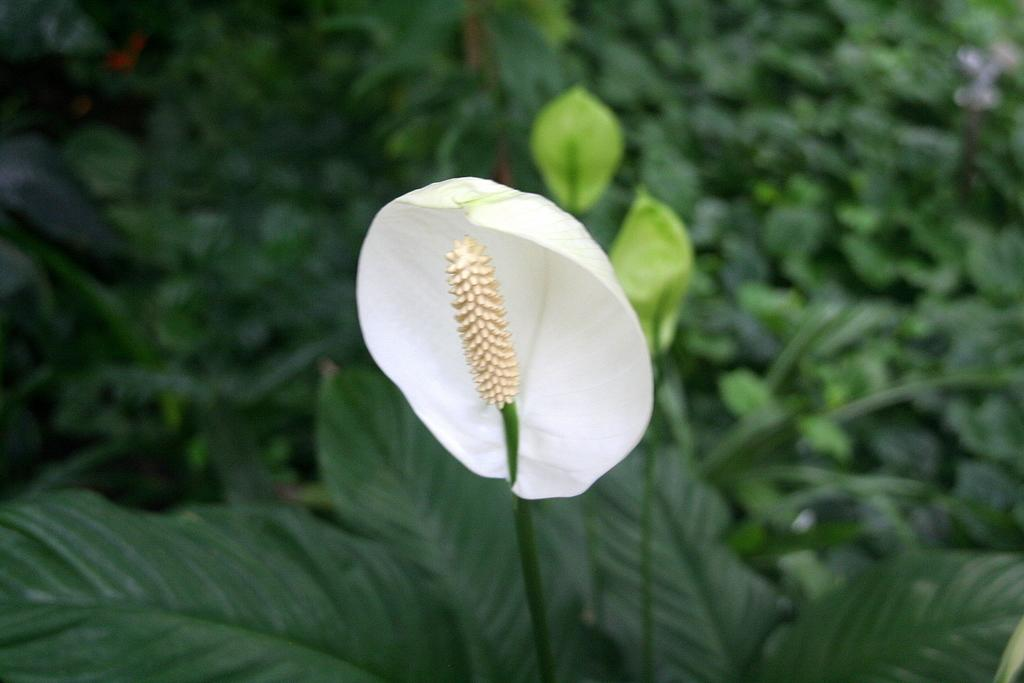What type of plants can be seen in the image? There are flower plants in the image. What is the color of the flower? The flower is white in color. Can you describe the background of the image? The background of the image is blurred. What type of channel is visible in the image? There is no channel present in the image; it features flower plants with a white flower and a blurred background. 